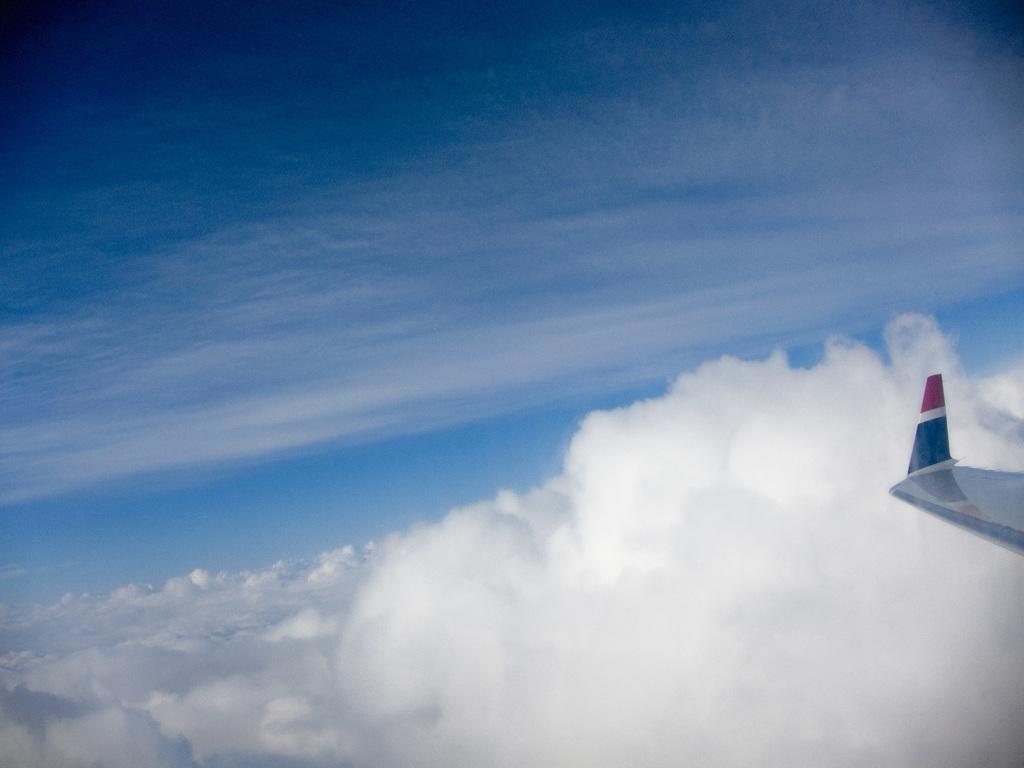What can be seen in the sky in the image? There are clouds in the sky in the image. What else is visible in the image besides the clouds? A part of a plane wing is visible in the image. What colors are present on the plane wing? The plane wing has red and blue colors. Where is the crown located in the image? There is no crown present in the image. How many kittens can be seen playing with the juice in the image? There are no kittens or juice present in the image. 